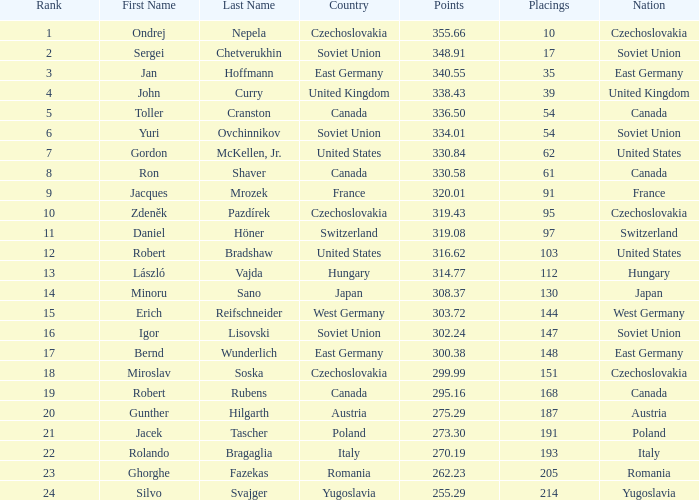43? None. 